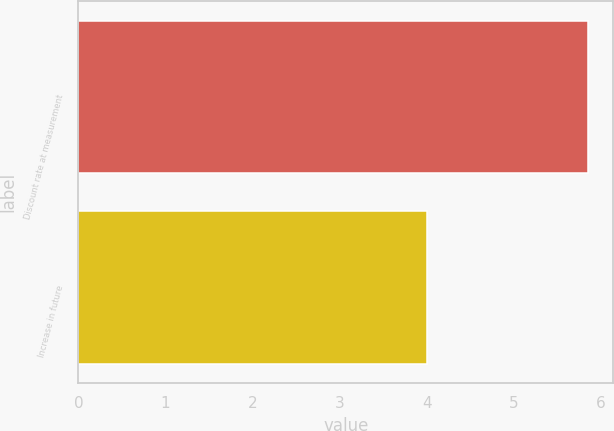<chart> <loc_0><loc_0><loc_500><loc_500><bar_chart><fcel>Discount rate at measurement<fcel>Increase in future<nl><fcel>5.85<fcel>4<nl></chart> 